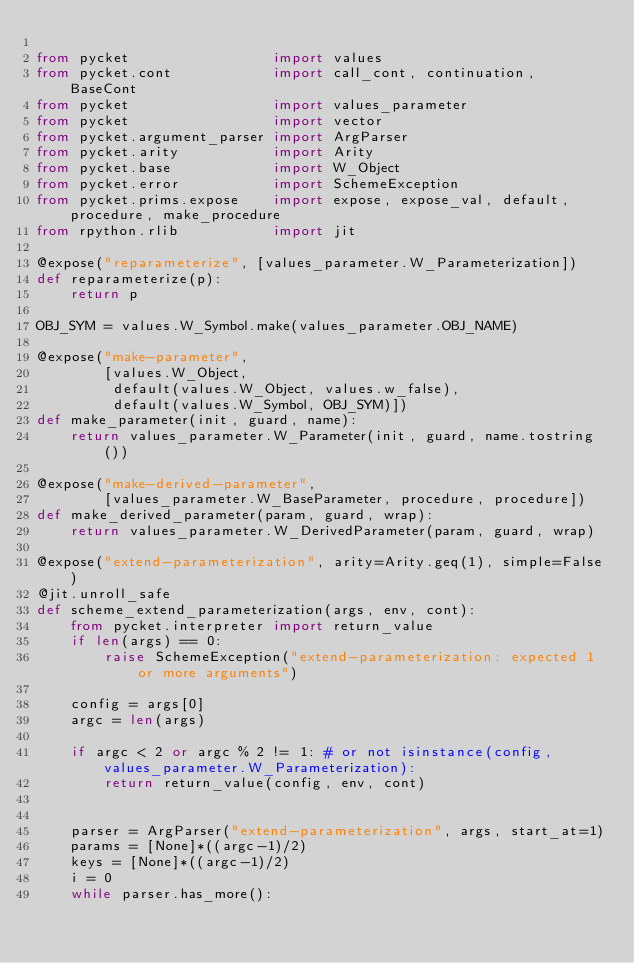Convert code to text. <code><loc_0><loc_0><loc_500><loc_500><_Python_>
from pycket                 import values
from pycket.cont            import call_cont, continuation, BaseCont
from pycket                 import values_parameter
from pycket                 import vector
from pycket.argument_parser import ArgParser
from pycket.arity           import Arity
from pycket.base            import W_Object
from pycket.error           import SchemeException
from pycket.prims.expose    import expose, expose_val, default, procedure, make_procedure
from rpython.rlib           import jit

@expose("reparameterize", [values_parameter.W_Parameterization])
def reparameterize(p):
    return p

OBJ_SYM = values.W_Symbol.make(values_parameter.OBJ_NAME)

@expose("make-parameter",
        [values.W_Object,
         default(values.W_Object, values.w_false),
         default(values.W_Symbol, OBJ_SYM)])
def make_parameter(init, guard, name):
    return values_parameter.W_Parameter(init, guard, name.tostring())

@expose("make-derived-parameter",
        [values_parameter.W_BaseParameter, procedure, procedure])
def make_derived_parameter(param, guard, wrap):
    return values_parameter.W_DerivedParameter(param, guard, wrap)

@expose("extend-parameterization", arity=Arity.geq(1), simple=False)
@jit.unroll_safe
def scheme_extend_parameterization(args, env, cont):
    from pycket.interpreter import return_value
    if len(args) == 0:
        raise SchemeException("extend-parameterization: expected 1 or more arguments")

    config = args[0]
    argc = len(args)

    if argc < 2 or argc % 2 != 1: # or not isinstance(config, values_parameter.W_Parameterization):
        return return_value(config, env, cont)


    parser = ArgParser("extend-parameterization", args, start_at=1)
    params = [None]*((argc-1)/2)
    keys = [None]*((argc-1)/2)
    i = 0
    while parser.has_more():</code> 